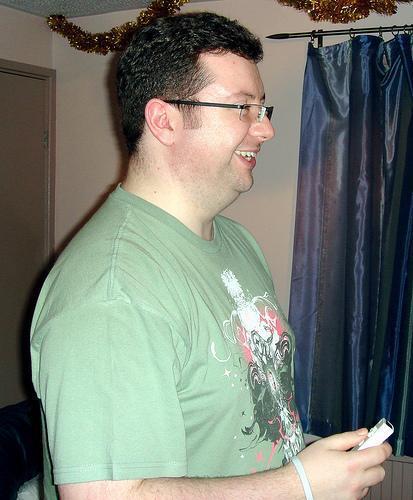How many people in the picture?
Give a very brief answer. 1. 